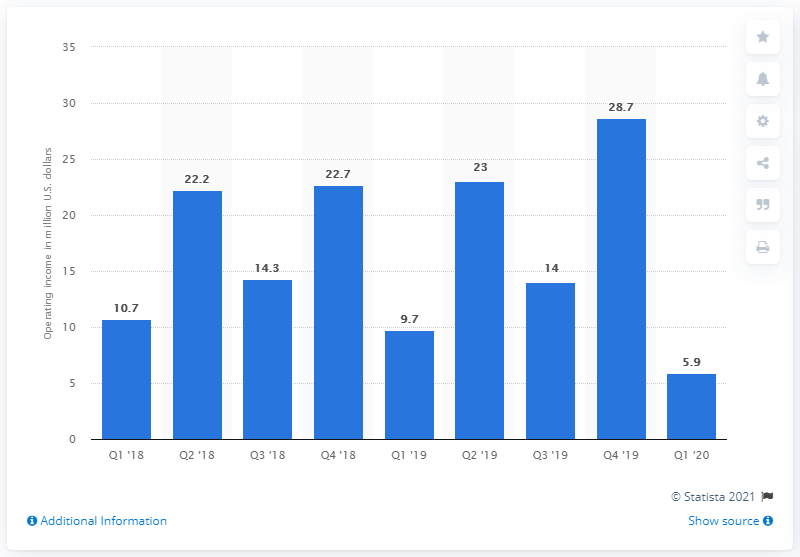What could be the reasons for the peak and decline in operating income shown on the chart? Reasons for fluctuations in operating income can include seasonal sales impacts, changes in consumer behavior, marketing efforts, operational costs, and broader economic conditions. The peak in Q4 '19 could be due to high sales typically seen in the holiday season, while the decline in Q1 '20 might reflect post-holiday season slowdown or other market factors. 